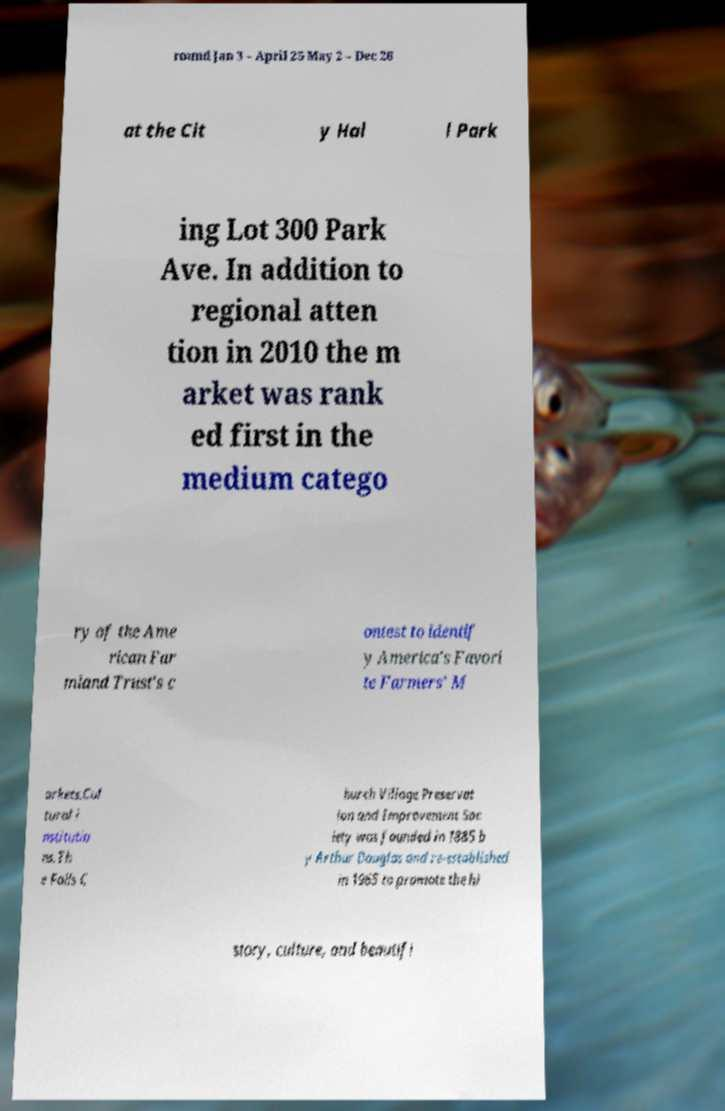Please read and relay the text visible in this image. What does it say? round Jan 3 – April 25 May 2 – Dec 26 at the Cit y Hal l Park ing Lot 300 Park Ave. In addition to regional atten tion in 2010 the m arket was rank ed first in the medium catego ry of the Ame rican Far mland Trust's c ontest to identif y America's Favori te Farmers' M arkets.Cul tural i nstitutio ns.Th e Falls C hurch Village Preservat ion and Improvement Soc iety was founded in 1885 b y Arthur Douglas and re-established in 1965 to promote the hi story, culture, and beautifi 